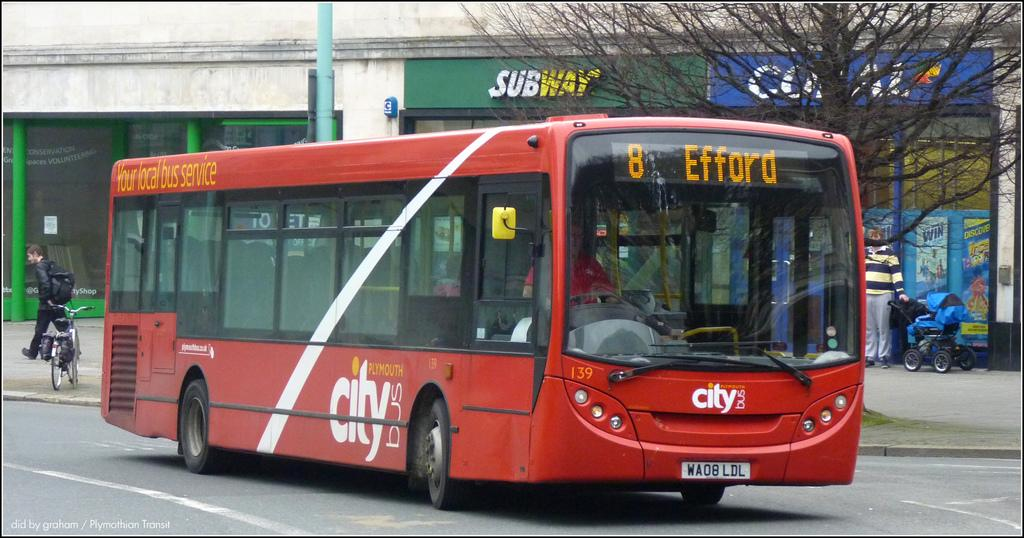<image>
Render a clear and concise summary of the photo. The big red city bus is stopping at efford 